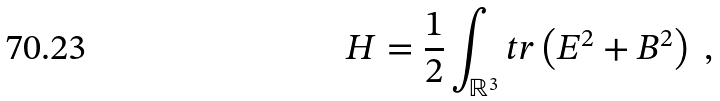Convert formula to latex. <formula><loc_0><loc_0><loc_500><loc_500>H = \frac { 1 } { 2 } \int _ { \mathbb { R } ^ { 3 } } t r \left ( E ^ { 2 } + B ^ { 2 } \right ) \ ,</formula> 